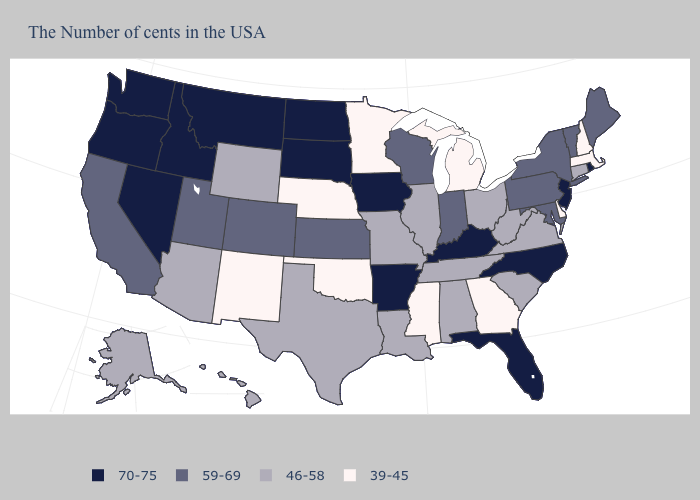Does Georgia have the lowest value in the USA?
Short answer required. Yes. Does Minnesota have the lowest value in the MidWest?
Answer briefly. Yes. Name the states that have a value in the range 59-69?
Write a very short answer. Maine, Vermont, New York, Maryland, Pennsylvania, Indiana, Wisconsin, Kansas, Colorado, Utah, California. How many symbols are there in the legend?
Keep it brief. 4. What is the value of Vermont?
Concise answer only. 59-69. Is the legend a continuous bar?
Answer briefly. No. What is the highest value in the South ?
Be succinct. 70-75. What is the value of New Jersey?
Keep it brief. 70-75. What is the value of Virginia?
Write a very short answer. 46-58. Does Delaware have the lowest value in the South?
Concise answer only. Yes. Which states have the highest value in the USA?
Short answer required. Rhode Island, New Jersey, North Carolina, Florida, Kentucky, Arkansas, Iowa, South Dakota, North Dakota, Montana, Idaho, Nevada, Washington, Oregon. What is the lowest value in states that border New York?
Concise answer only. 39-45. What is the lowest value in states that border Oklahoma?
Answer briefly. 39-45. What is the value of Nevada?
Short answer required. 70-75. Does Maryland have the lowest value in the USA?
Write a very short answer. No. 